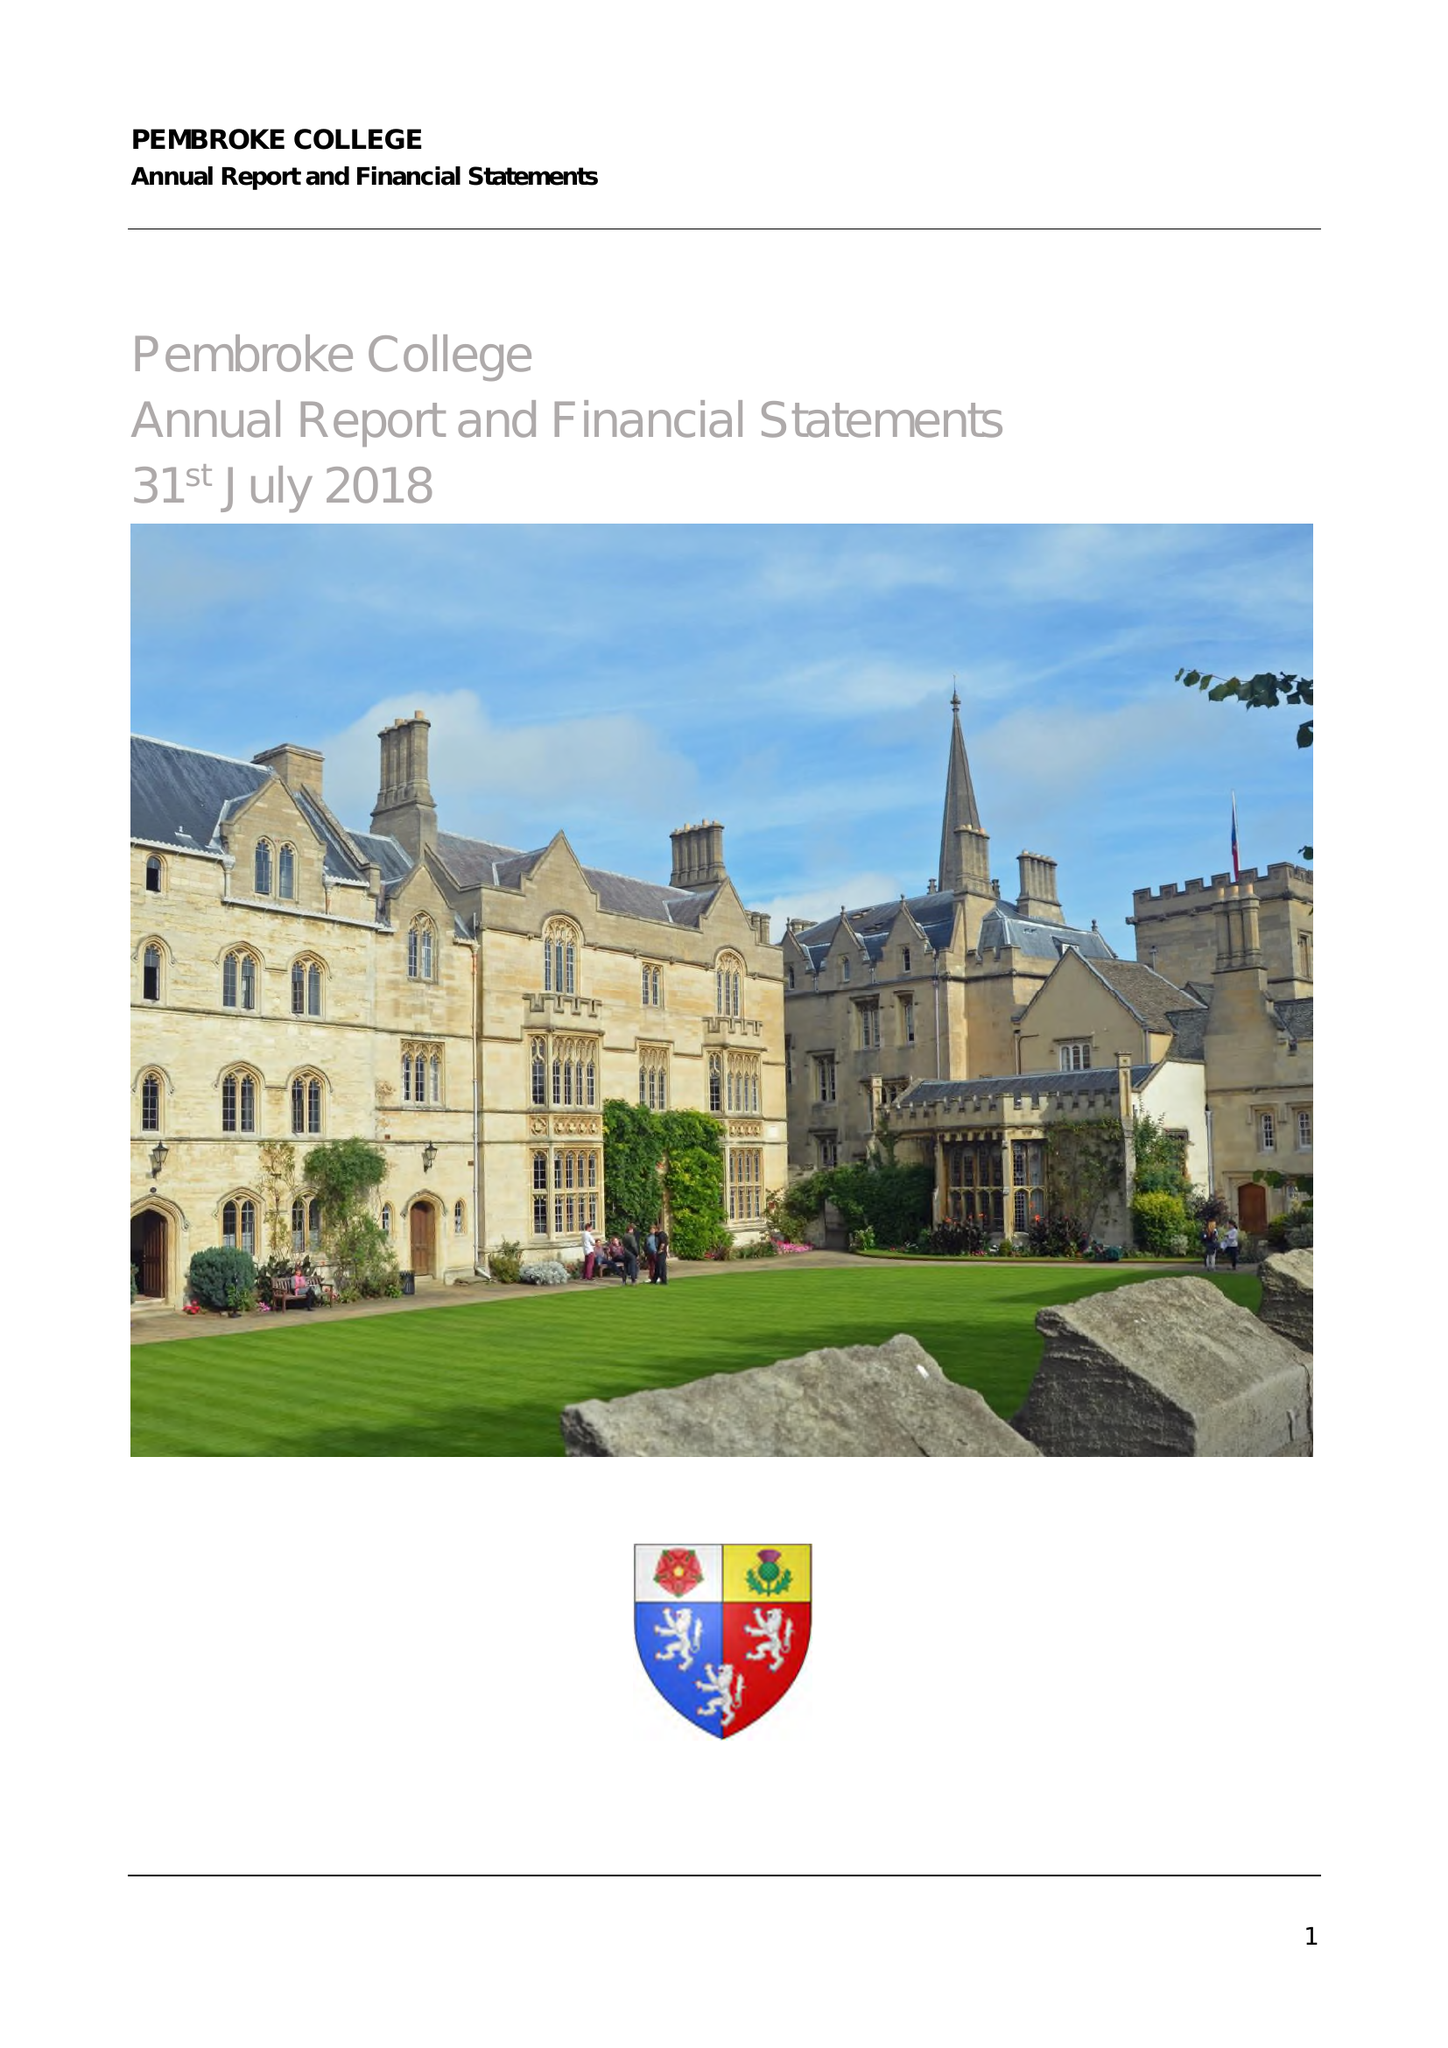What is the value for the income_annually_in_british_pounds?
Answer the question using a single word or phrase. 12711000.00 